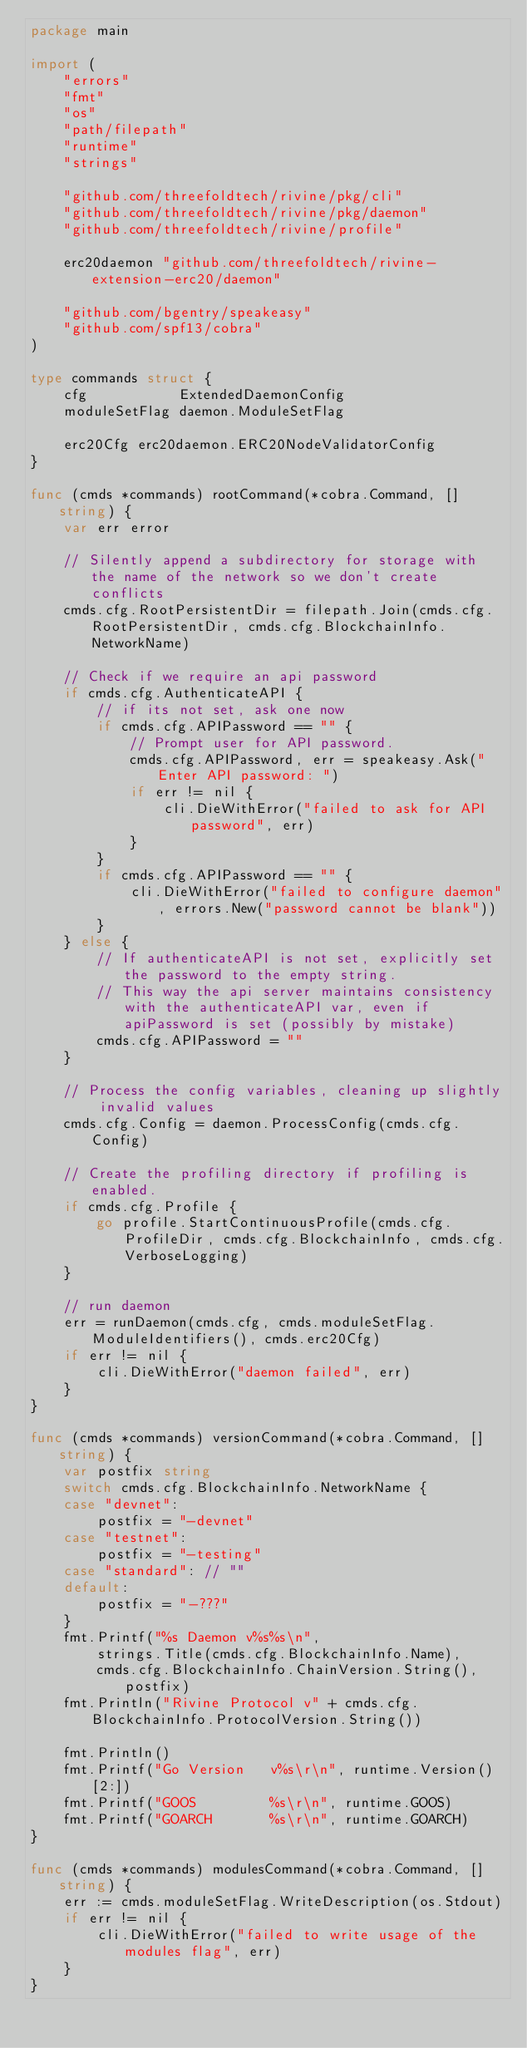Convert code to text. <code><loc_0><loc_0><loc_500><loc_500><_Go_>package main

import (
	"errors"
	"fmt"
	"os"
	"path/filepath"
	"runtime"
	"strings"

	"github.com/threefoldtech/rivine/pkg/cli"
	"github.com/threefoldtech/rivine/pkg/daemon"
	"github.com/threefoldtech/rivine/profile"

	erc20daemon "github.com/threefoldtech/rivine-extension-erc20/daemon"

	"github.com/bgentry/speakeasy"
	"github.com/spf13/cobra"
)

type commands struct {
	cfg           ExtendedDaemonConfig
	moduleSetFlag daemon.ModuleSetFlag

	erc20Cfg erc20daemon.ERC20NodeValidatorConfig
}

func (cmds *commands) rootCommand(*cobra.Command, []string) {
	var err error

	// Silently append a subdirectory for storage with the name of the network so we don't create conflicts
	cmds.cfg.RootPersistentDir = filepath.Join(cmds.cfg.RootPersistentDir, cmds.cfg.BlockchainInfo.NetworkName)

	// Check if we require an api password
	if cmds.cfg.AuthenticateAPI {
		// if its not set, ask one now
		if cmds.cfg.APIPassword == "" {
			// Prompt user for API password.
			cmds.cfg.APIPassword, err = speakeasy.Ask("Enter API password: ")
			if err != nil {
				cli.DieWithError("failed to ask for API password", err)
			}
		}
		if cmds.cfg.APIPassword == "" {
			cli.DieWithError("failed to configure daemon", errors.New("password cannot be blank"))
		}
	} else {
		// If authenticateAPI is not set, explicitly set the password to the empty string.
		// This way the api server maintains consistency with the authenticateAPI var, even if apiPassword is set (possibly by mistake)
		cmds.cfg.APIPassword = ""
	}

	// Process the config variables, cleaning up slightly invalid values
	cmds.cfg.Config = daemon.ProcessConfig(cmds.cfg.Config)

	// Create the profiling directory if profiling is enabled.
	if cmds.cfg.Profile {
		go profile.StartContinuousProfile(cmds.cfg.ProfileDir, cmds.cfg.BlockchainInfo, cmds.cfg.VerboseLogging)
	}

	// run daemon
	err = runDaemon(cmds.cfg, cmds.moduleSetFlag.ModuleIdentifiers(), cmds.erc20Cfg)
	if err != nil {
		cli.DieWithError("daemon failed", err)
	}
}

func (cmds *commands) versionCommand(*cobra.Command, []string) {
	var postfix string
	switch cmds.cfg.BlockchainInfo.NetworkName {
	case "devnet":
		postfix = "-devnet"
	case "testnet":
		postfix = "-testing"
	case "standard": // ""
	default:
		postfix = "-???"
	}
	fmt.Printf("%s Daemon v%s%s\n",
		strings.Title(cmds.cfg.BlockchainInfo.Name),
		cmds.cfg.BlockchainInfo.ChainVersion.String(), postfix)
	fmt.Println("Rivine Protocol v" + cmds.cfg.BlockchainInfo.ProtocolVersion.String())

	fmt.Println()
	fmt.Printf("Go Version   v%s\r\n", runtime.Version()[2:])
	fmt.Printf("GOOS         %s\r\n", runtime.GOOS)
	fmt.Printf("GOARCH       %s\r\n", runtime.GOARCH)
}

func (cmds *commands) modulesCommand(*cobra.Command, []string) {
	err := cmds.moduleSetFlag.WriteDescription(os.Stdout)
	if err != nil {
		cli.DieWithError("failed to write usage of the modules flag", err)
	}
}
</code> 